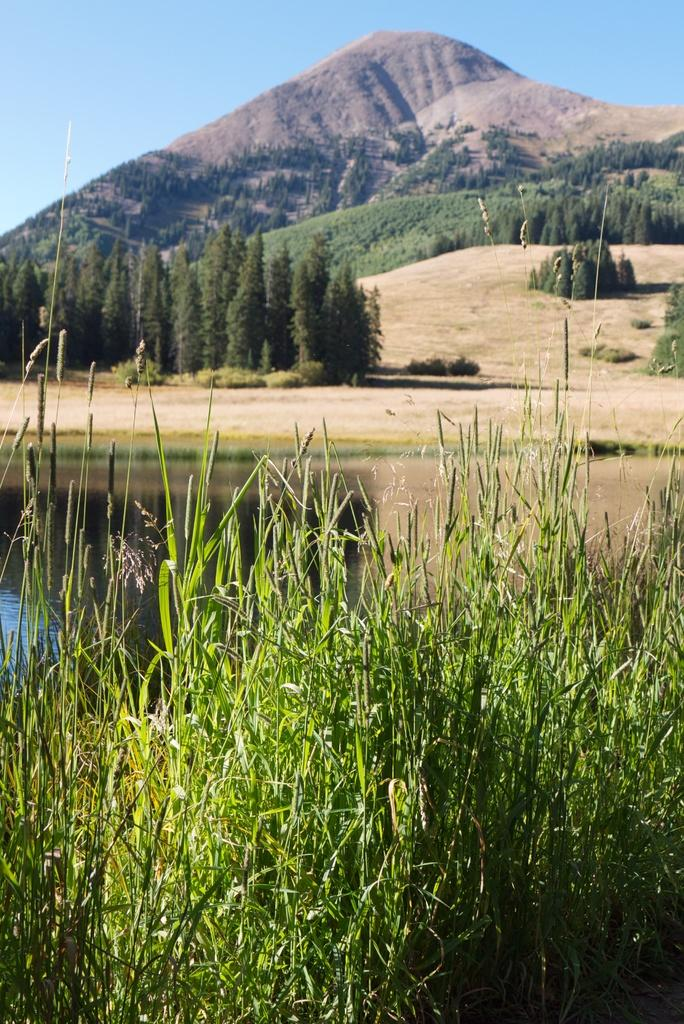What type of natural landform can be seen in the image? There are mountains in the image. What type of vegetation is present in the image? There are trees in the image. What body of water is visible in the image? There is water visible in the image. What type of ground cover is present in the image? There is green grass in the image. What is the color of the sky in the image? The sky is blue in color. What is the purpose of the pest in the image? There is no pest present in the image. Can you tell me how many people are swimming in the water in the image? There is no swimming or people visible in the image; it features mountains, trees, water, grass, and a blue sky. 